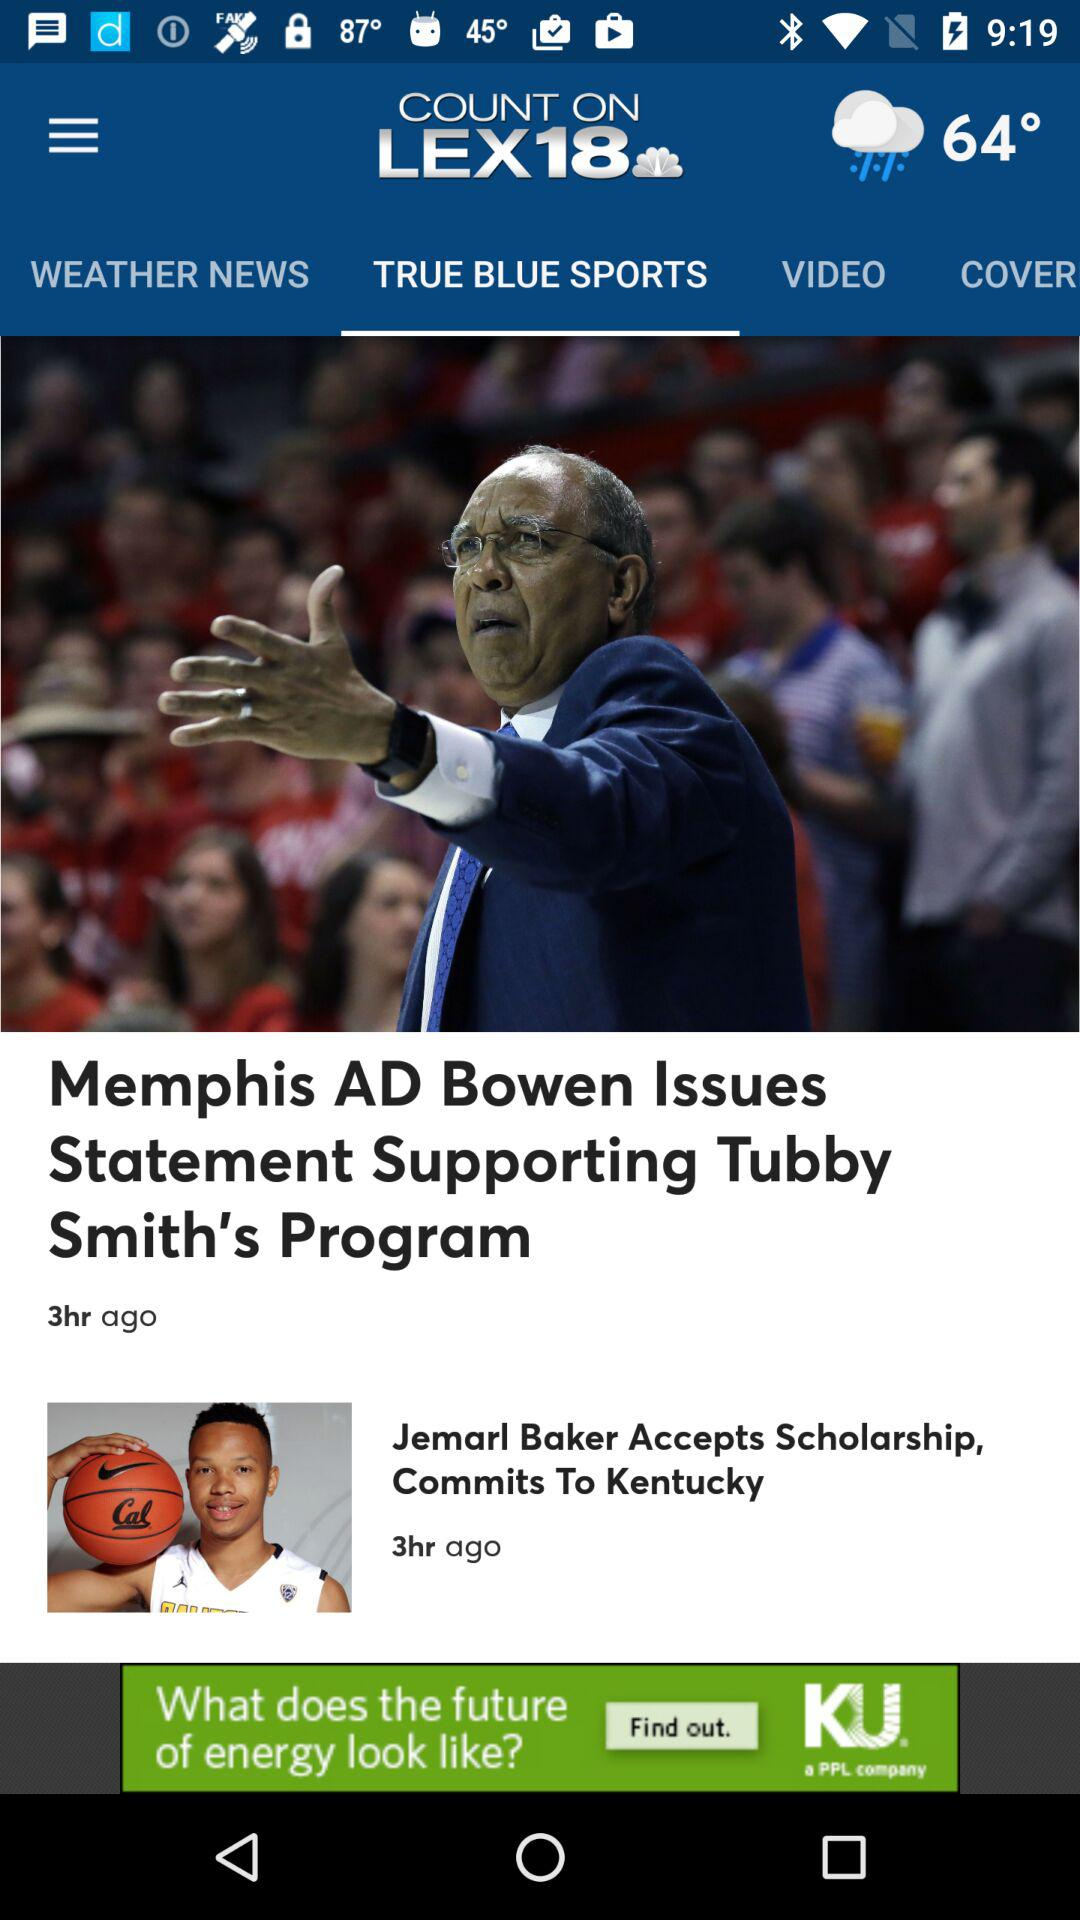What is the headline of the article? The headlines are "Memphis AD Bowen Issues Statement Supporting Tubby Smith's Program" and "Jemarl Baker Accepts Scholarship, Commits To Kentucky". 